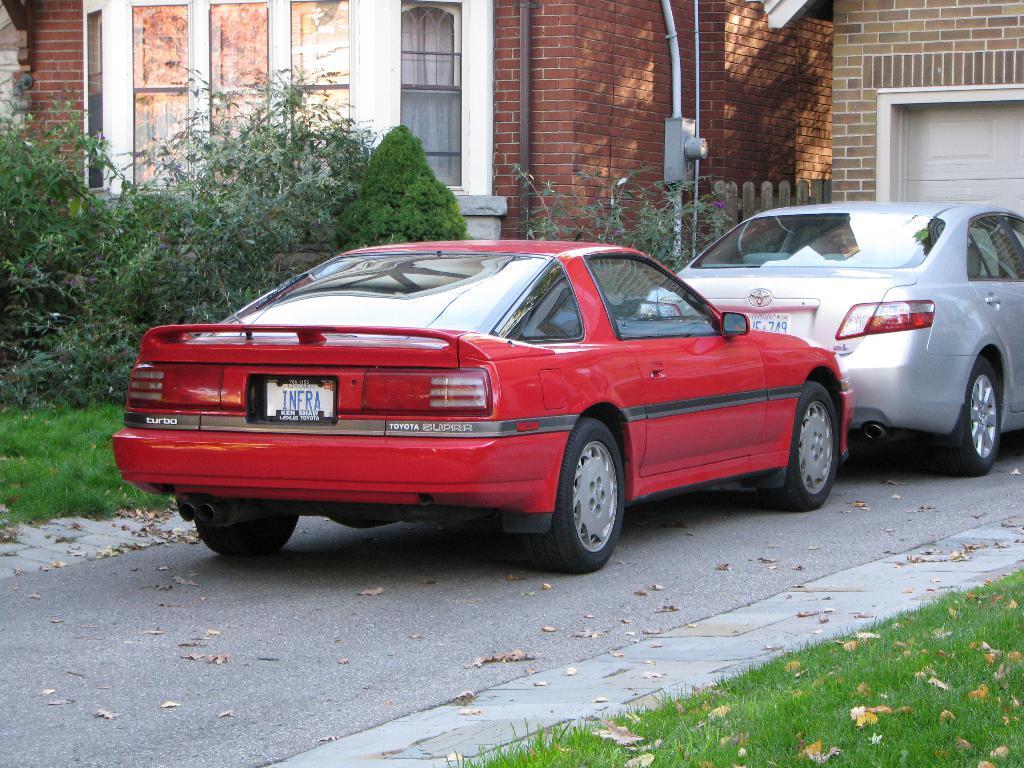Can you describe this image briefly? In this image I can see two cars on the road. In the background I can see a building, windows, pipes, plants, the grass and other objects. 